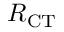Convert formula to latex. <formula><loc_0><loc_0><loc_500><loc_500>R _ { C T }</formula> 